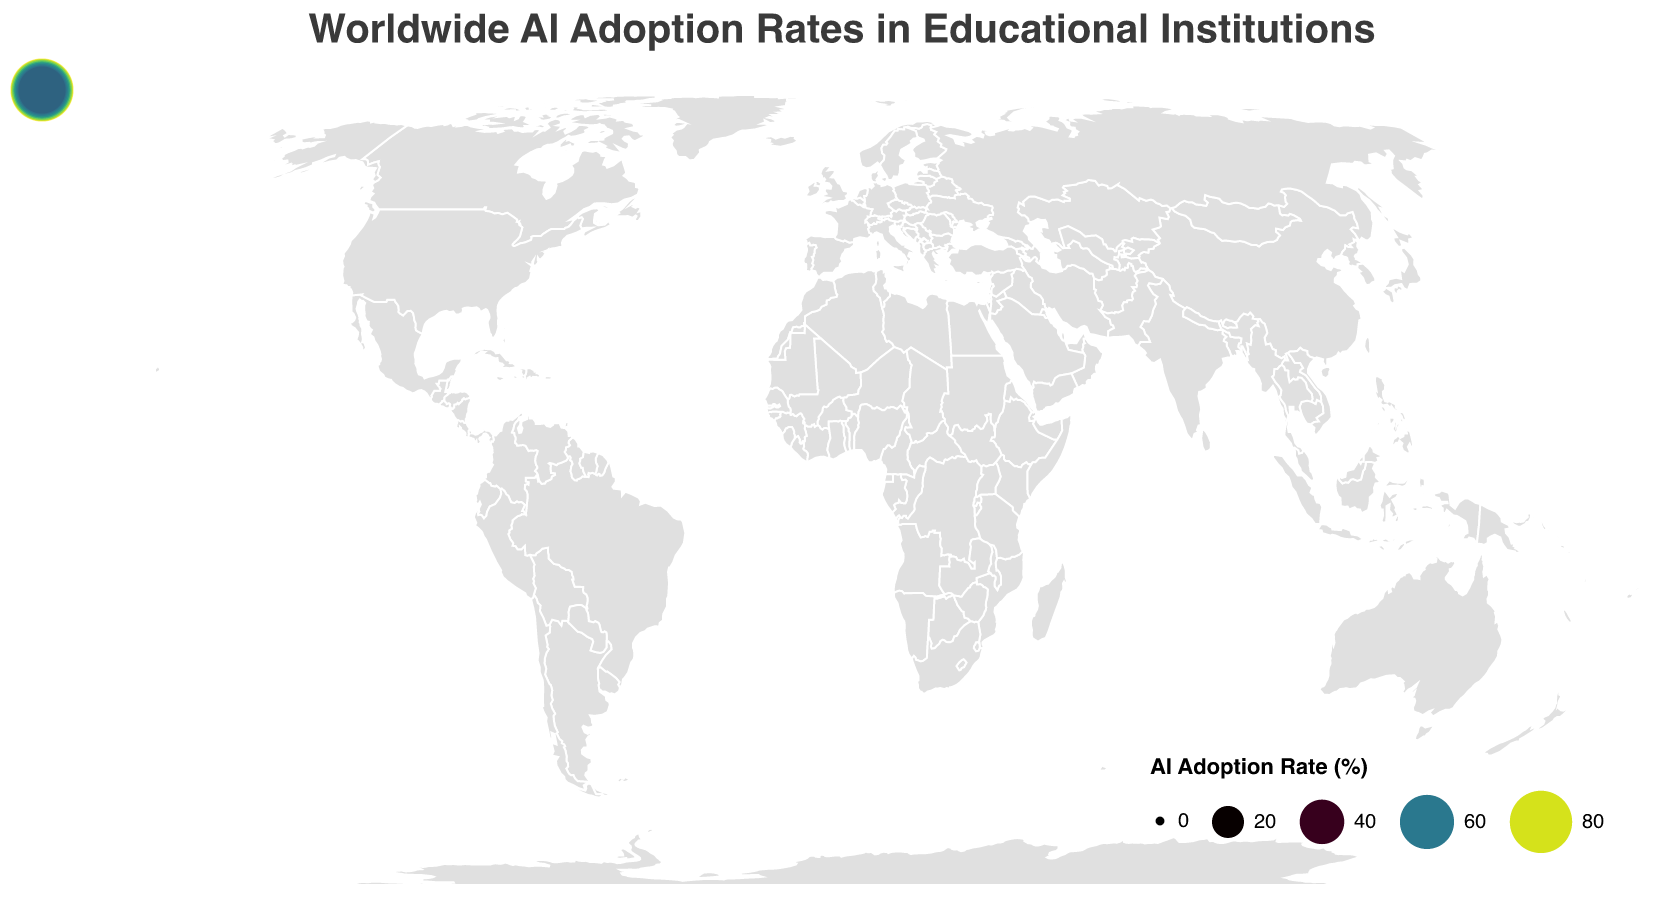What's the main title of the figure? The main title is located at the top of the figure, and it is designed to provide a summary of what the figure represents.
Answer: Worldwide AI Adoption Rates in Educational Institutions Which country has the highest AI adoption rate in educational institutions? By looking at the size of the circles and the color intensity, the country with the largest and darkest circle (indicative of the highest rate) can be identified.
Answer: China What is the AI adoption rate in Israel? The specific rate can be found by locating Israel's circle on the map and using the tooltip or color legend for precise value.
Answer: 79.1 How many countries have an AI adoption rate above 70%? Count all countries that have circles of size and color indicating an AI adoption rate above 70%. Use the legend for precise values.
Answer: 9 Which country has the lowest AI adoption rate, and what is the rate? Locate the smallest and lightest circle based on size and color, then verify the tooltip or legend for the exact rate.
Answer: South Africa, 45.2 Compare the AI adoption rates between Japan and India. Which country has a higher rate and by how much? Identify Japan and India's circles, use the tooltips or legend for their exact rates, and compute the difference.
Answer: Japan has a higher rate by 10.8 (69.7 - 58.9) What is the average AI adoption rate across all listed countries? Sum all the AI adoption rates shown on the map and then divide by the number of countries (20).
Answer: 66.7 What color scheme is used to represent the AI adoption rates? The legend indicates the color scheme used to convey different ranges of adoption rates.
Answer: Viridis Is there a noticeable regional pattern in AI adoption rates? Consider the geographic distribution of the circles’ sizes and colors to identify any visible trends or clusters by region.
Answer: Higher in Asia and North America 